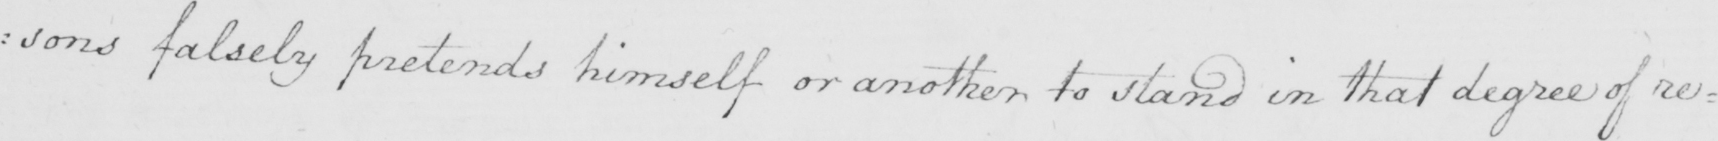What does this handwritten line say? : sons falsely pretends himself or another to stand in that degree of re= 